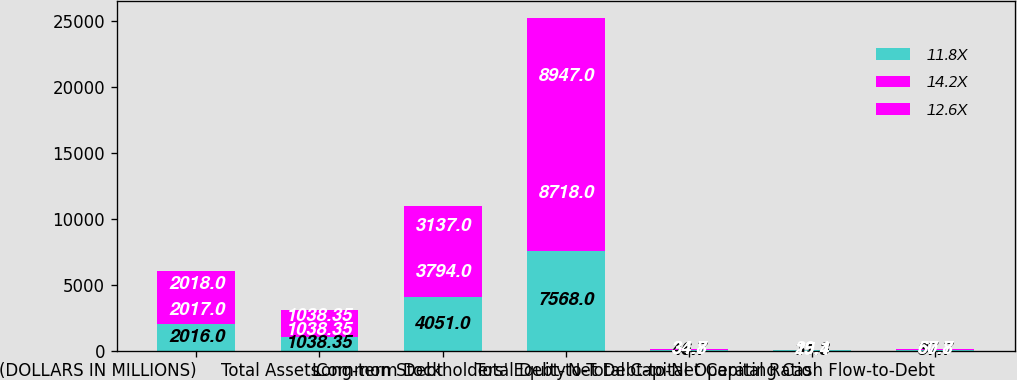<chart> <loc_0><loc_0><loc_500><loc_500><stacked_bar_chart><ecel><fcel>(DOLLARS IN MILLIONS)<fcel>Total Assets<fcel>Long-term Debt<fcel>Common Stockholders' Equity<fcel>Total Debt-to-Total Capital<fcel>Net Debt-to-Net Capital Ratio<fcel>Operating Cash Flow-to-Debt<nl><fcel>11.8X<fcel>2016<fcel>1038.35<fcel>4051<fcel>7568<fcel>46.7<fcel>31.3<fcel>37.7<nl><fcel>14.2X<fcel>2017<fcel>1038.35<fcel>3794<fcel>8718<fcel>34.8<fcel>15.4<fcel>57.8<nl><fcel>12.6X<fcel>2018<fcel>1038.35<fcel>3137<fcel>8947<fcel>34.7<fcel>29.1<fcel>60.7<nl></chart> 